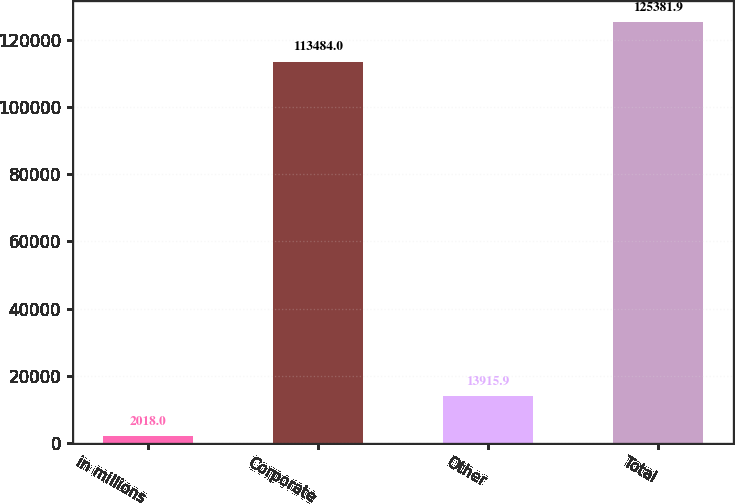Convert chart to OTSL. <chart><loc_0><loc_0><loc_500><loc_500><bar_chart><fcel>in millions<fcel>Corporate<fcel>Other<fcel>Total<nl><fcel>2018<fcel>113484<fcel>13915.9<fcel>125382<nl></chart> 